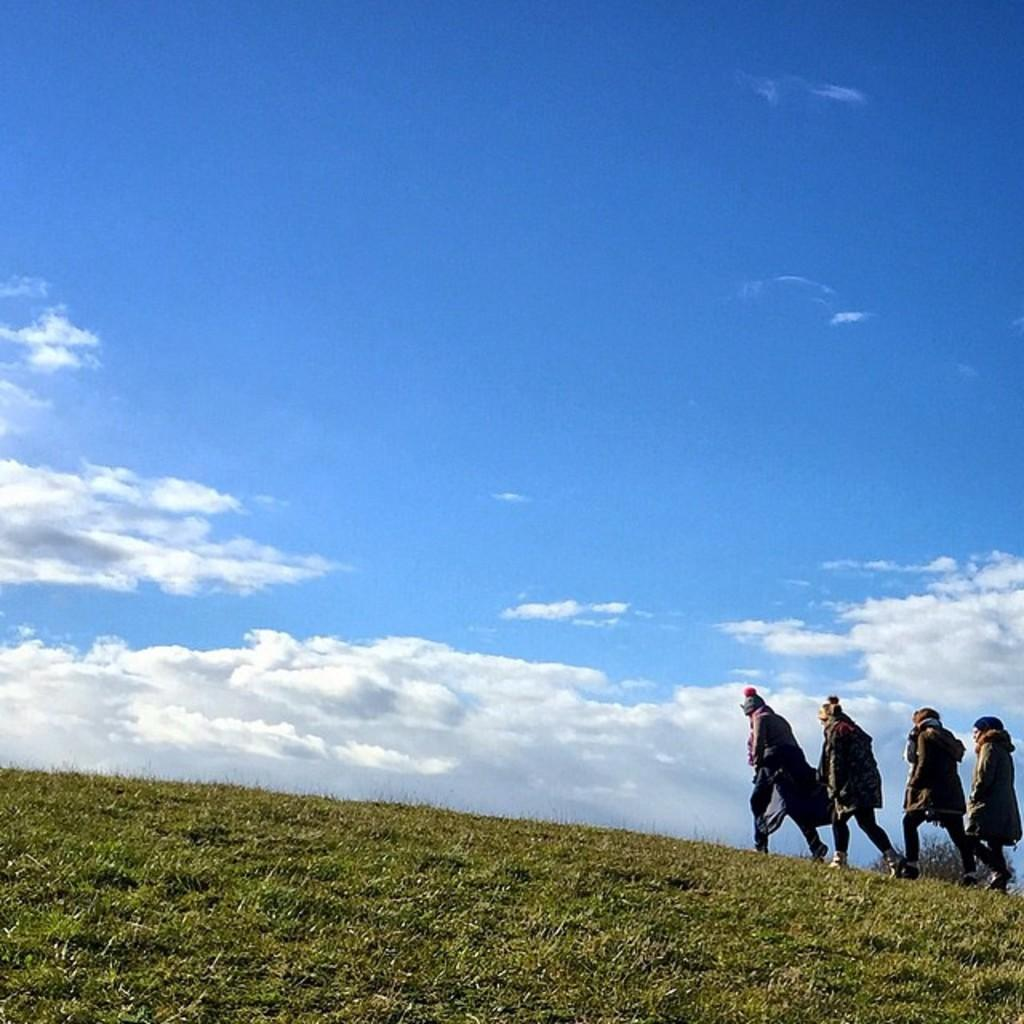What are the people in the image doing? The people in the image are walking. How can you describe the clothing of the people in the image? The people are wearing different dress. What type of terrain can be seen in the image? There is grass visible in the image. What colors are present in the sky in the image? The sky is in white and blue color. What time of day is it in the image, based on the hour? The provided facts do not mention the time of day or any specific hour, so it cannot be determined from the image. How do the people in the image express disgust? There is no indication of disgust in the image; the people are simply walking. Is there a tiger present in the image? No, there is no tiger in the image. 